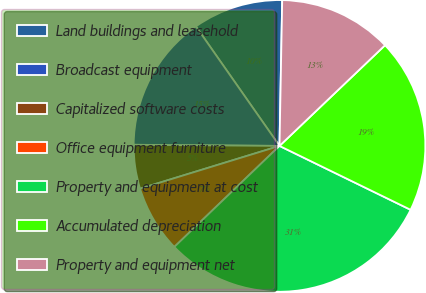Convert chart to OTSL. <chart><loc_0><loc_0><loc_500><loc_500><pie_chart><fcel>Land buildings and leasehold<fcel>Broadcast equipment<fcel>Capitalized software costs<fcel>Office equipment furniture<fcel>Property and equipment at cost<fcel>Accumulated depreciation<fcel>Property and equipment net<nl><fcel>10.01%<fcel>15.16%<fcel>4.86%<fcel>7.44%<fcel>30.6%<fcel>19.34%<fcel>12.58%<nl></chart> 